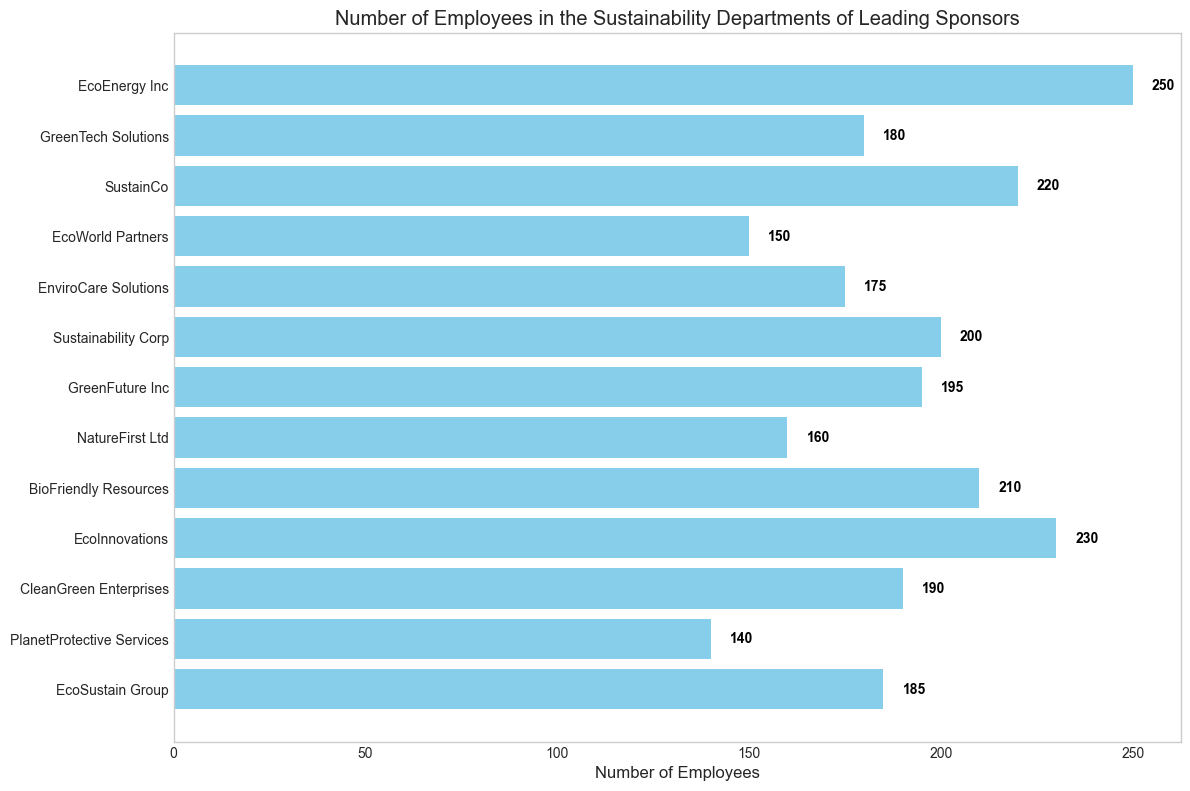What company has the highest number of employees in their sustainability department? The bar representing EcoEnergy Inc is the longest, indicating it has the highest number of employees.
Answer: EcoEnergy Inc Which company has the second highest number of employees in their sustainability department? The second longest bar on the chart corresponds to EcoInnovations.
Answer: EcoInnovations Which company has fewer employees: GreenTech Solutions or EcoSustain Group? The length of the bar for GreenTech Solutions is longer than the bar for EcoSustain Group.
Answer: EcoSustain Group What is the total number of employees across all companies? Sum the values of all the bars: 250 + 180 + 220 + 150 + 175 + 200 + 195 + 160 + 210 + 230 + 190 + 140 + 185 = 2385.
Answer: 2385 What is the difference in the number of employees between BioFriendly Resources and NatureFirst Ltd? Subtract the number of employees of NatureFirst Ltd from BioFriendly Resources: 210 - 160 = 50.
Answer: 50 Which companies have more than 200 employees in their sustainability departments? The bars that extend beyond the 200 mark are EcoEnergy Inc (250), SustainCo (220), BioFriendly Resources (210), and EcoInnovations (230).
Answer: EcoEnergy Inc, SustainCo, BioFriendly Resources, EcoInnovations Which company has the fewest employees in their sustainability department? The shortest bar on the chart corresponds to PlanetProtective Services.
Answer: PlanetProtective Services What is the average number of employees in the sustainability departments across all companies? Average is calculated by dividing the total number of employees by the number of companies: 2385 / 13 ≈ 183.46.
Answer: 183.46 Are there more employees in the sustainability departments of GreenTech Solutions or CleanGreen Enterprises? The length of the bar for CleanGreen Enterprises is longer than the bar for GreenTech Solutions.
Answer: CleanGreen Enterprises 